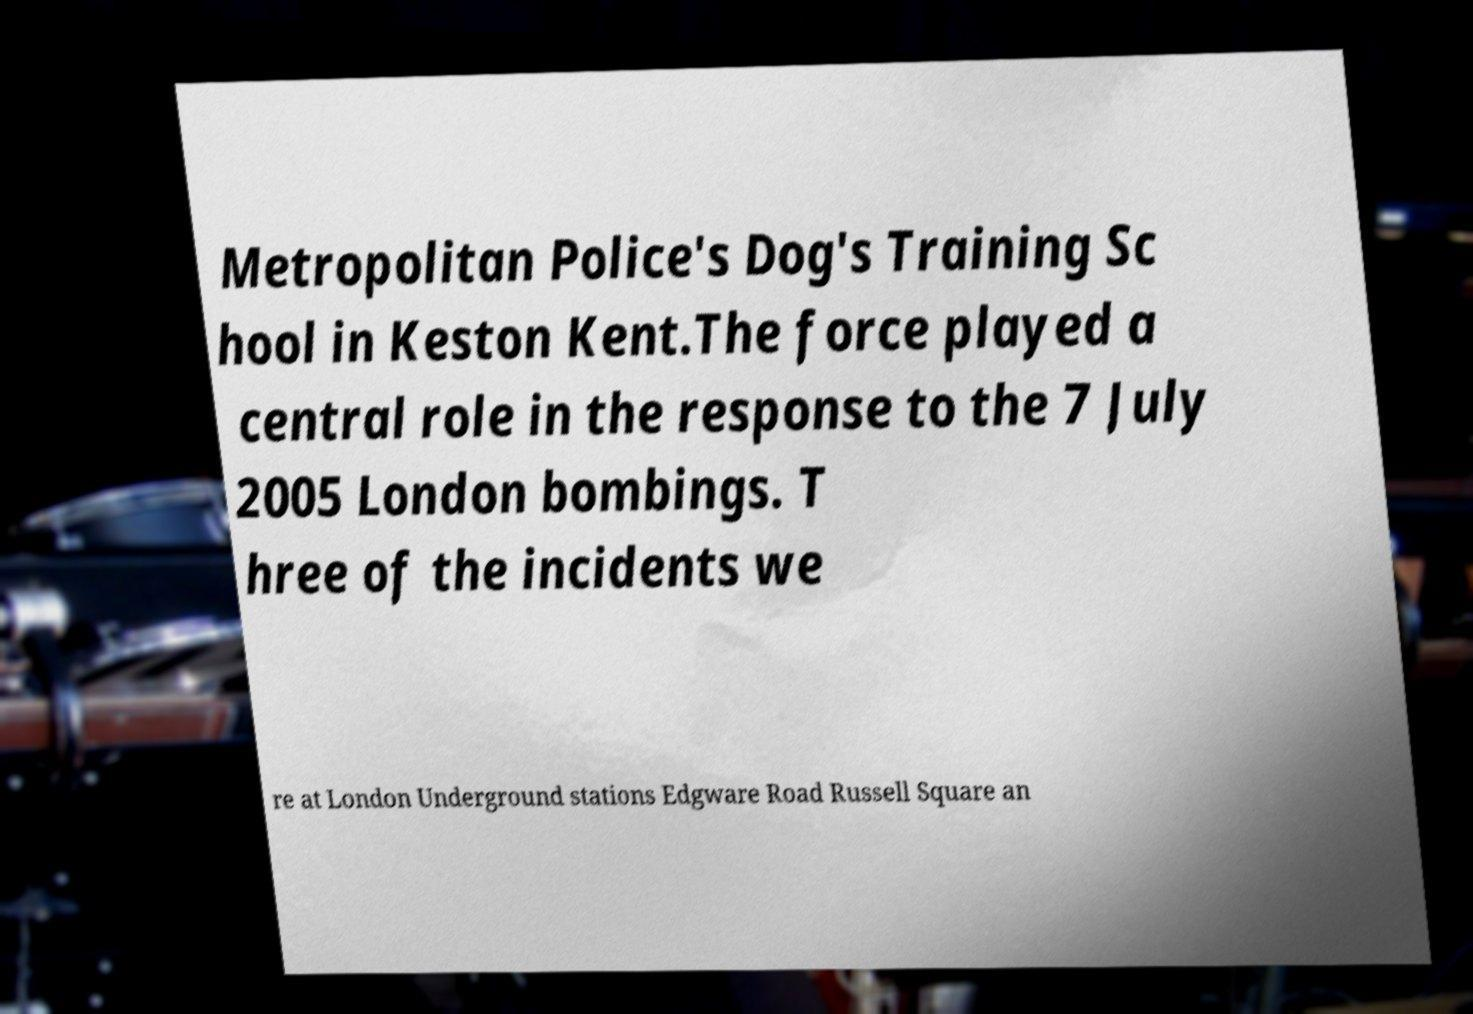Please read and relay the text visible in this image. What does it say? Metropolitan Police's Dog's Training Sc hool in Keston Kent.The force played a central role in the response to the 7 July 2005 London bombings. T hree of the incidents we re at London Underground stations Edgware Road Russell Square an 